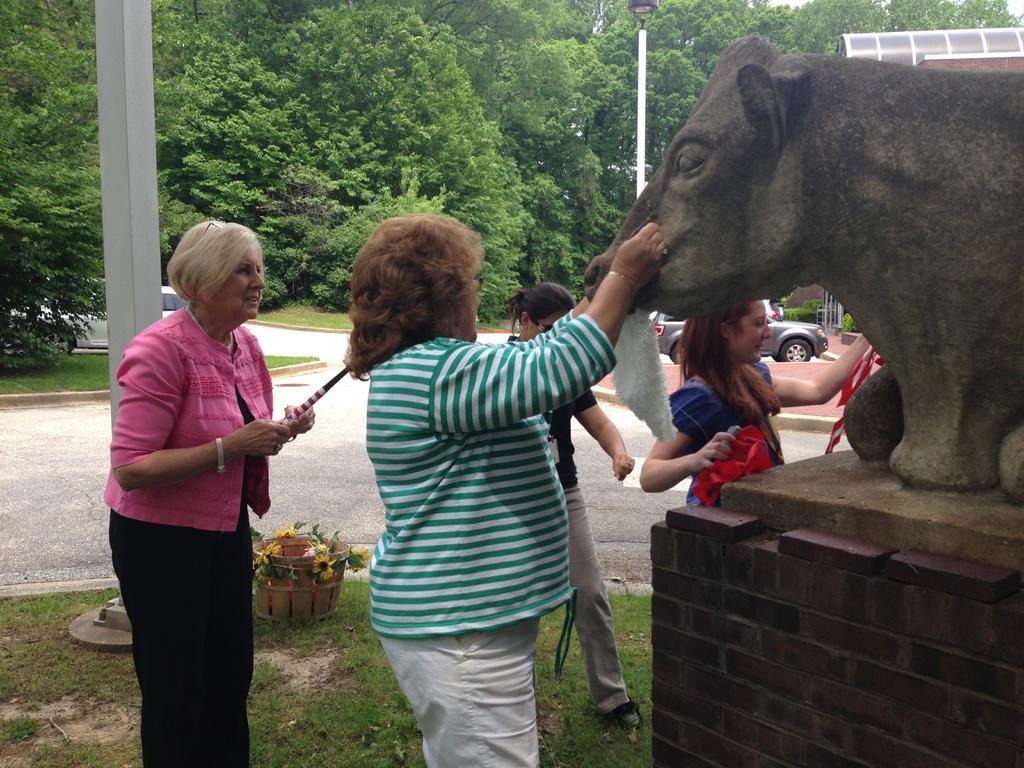Please provide a concise description of this image. In this image I can see a person wearing green and white t shirt and white pant is standing and holding a sculpture of an animal which is made of rock and I can see another woman wearing pink and black dress is standing and holding a stick in her hand. In the background I can see the road, few persons standing on the ground, a car on the road, few poles and few trees. 